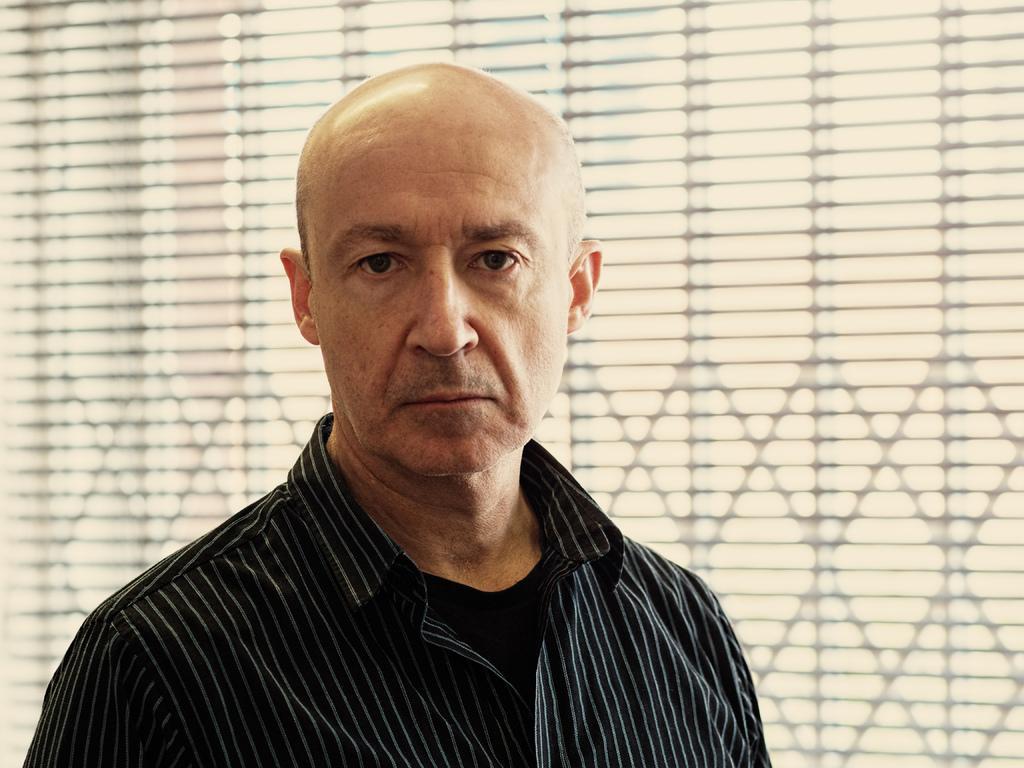In one or two sentences, can you explain what this image depicts? In the center of the image there is a person. In the background there is window. 